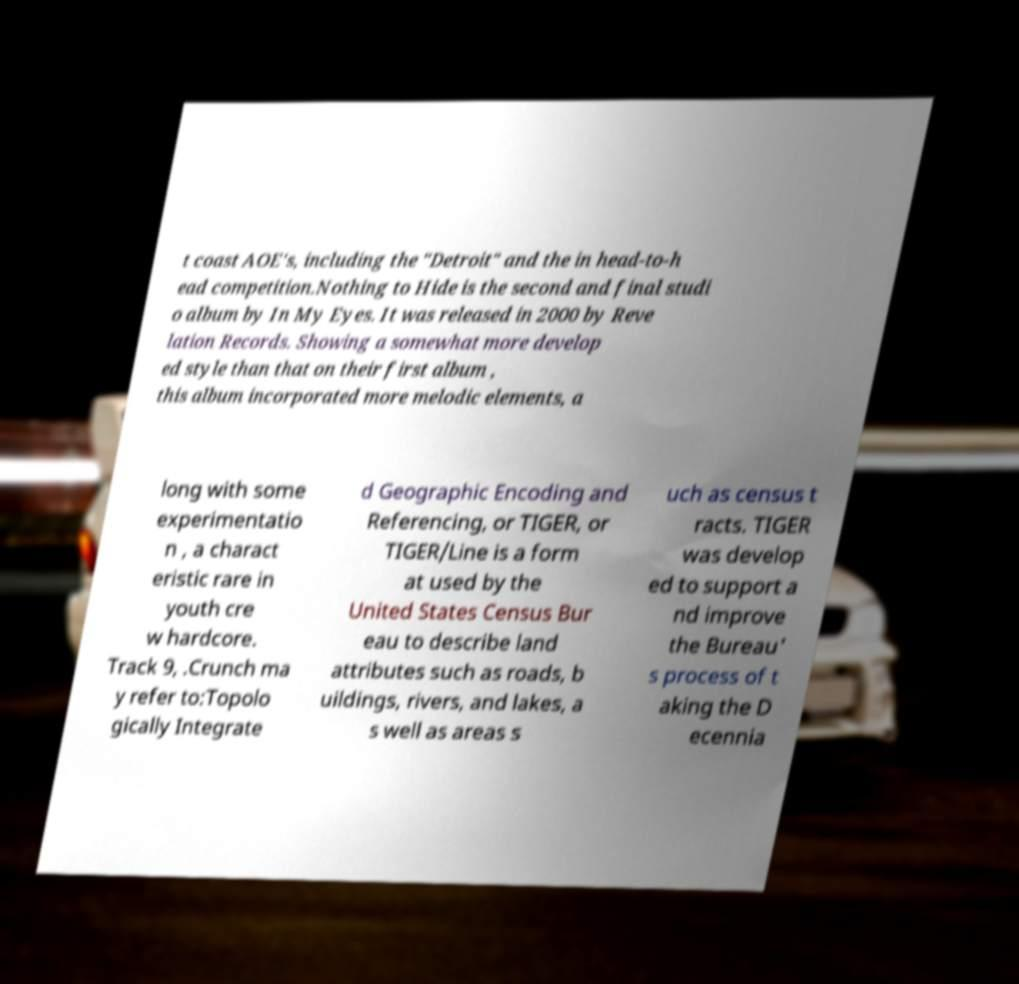Please read and relay the text visible in this image. What does it say? t coast AOE's, including the "Detroit" and the in head-to-h ead competition.Nothing to Hide is the second and final studi o album by In My Eyes. It was released in 2000 by Reve lation Records. Showing a somewhat more develop ed style than that on their first album , this album incorporated more melodic elements, a long with some experimentatio n , a charact eristic rare in youth cre w hardcore. Track 9, .Crunch ma y refer to:Topolo gically Integrate d Geographic Encoding and Referencing, or TIGER, or TIGER/Line is a form at used by the United States Census Bur eau to describe land attributes such as roads, b uildings, rivers, and lakes, a s well as areas s uch as census t racts. TIGER was develop ed to support a nd improve the Bureau' s process of t aking the D ecennia 